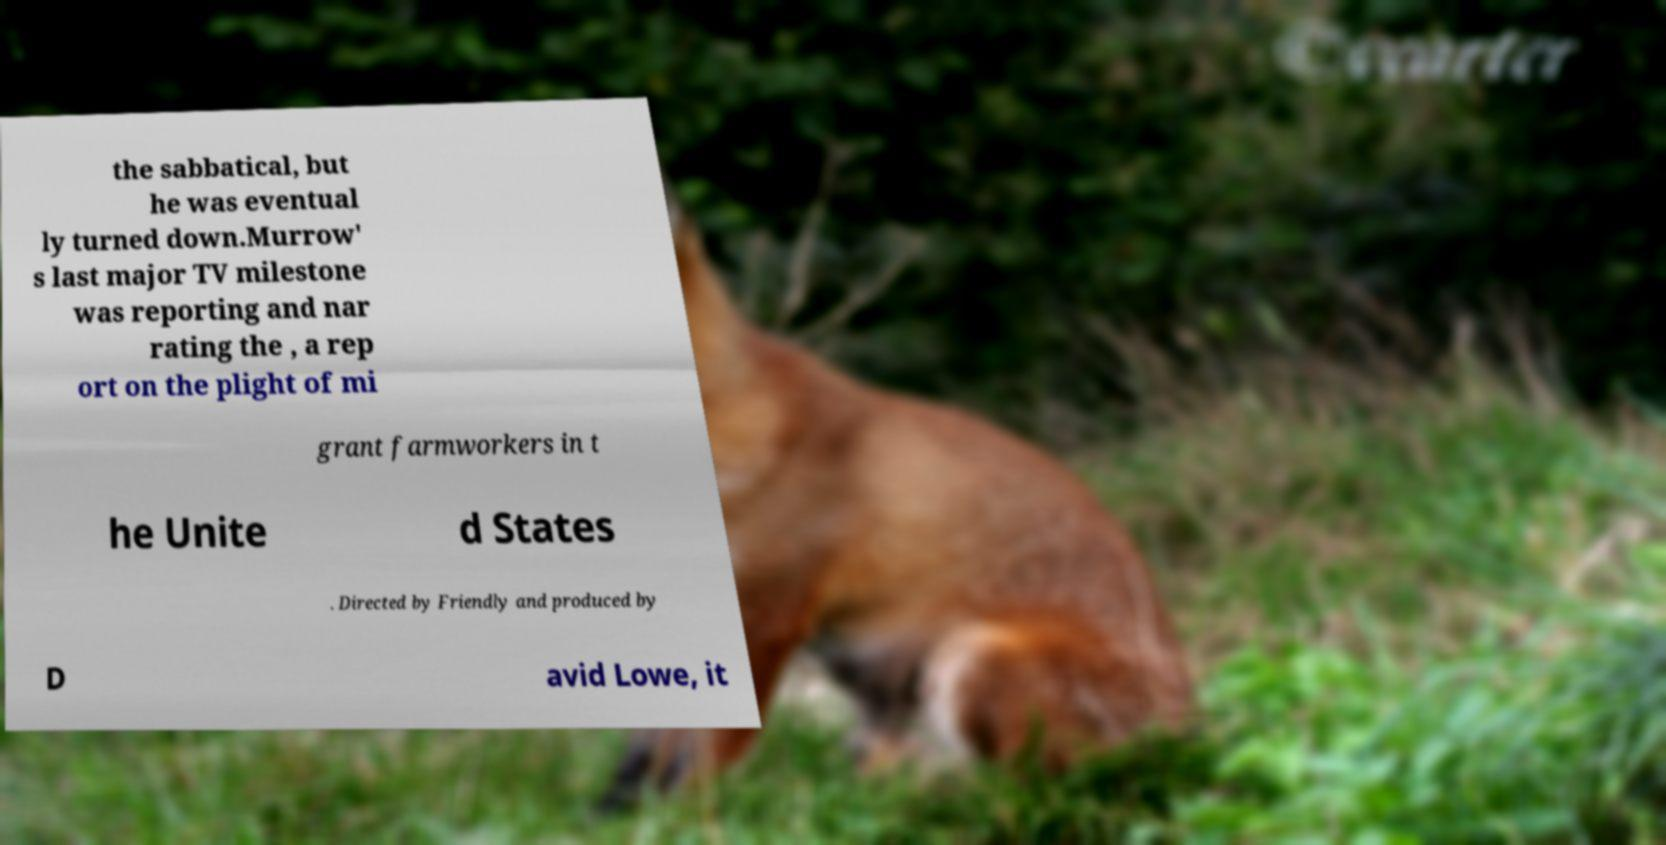Please identify and transcribe the text found in this image. the sabbatical, but he was eventual ly turned down.Murrow' s last major TV milestone was reporting and nar rating the , a rep ort on the plight of mi grant farmworkers in t he Unite d States . Directed by Friendly and produced by D avid Lowe, it 